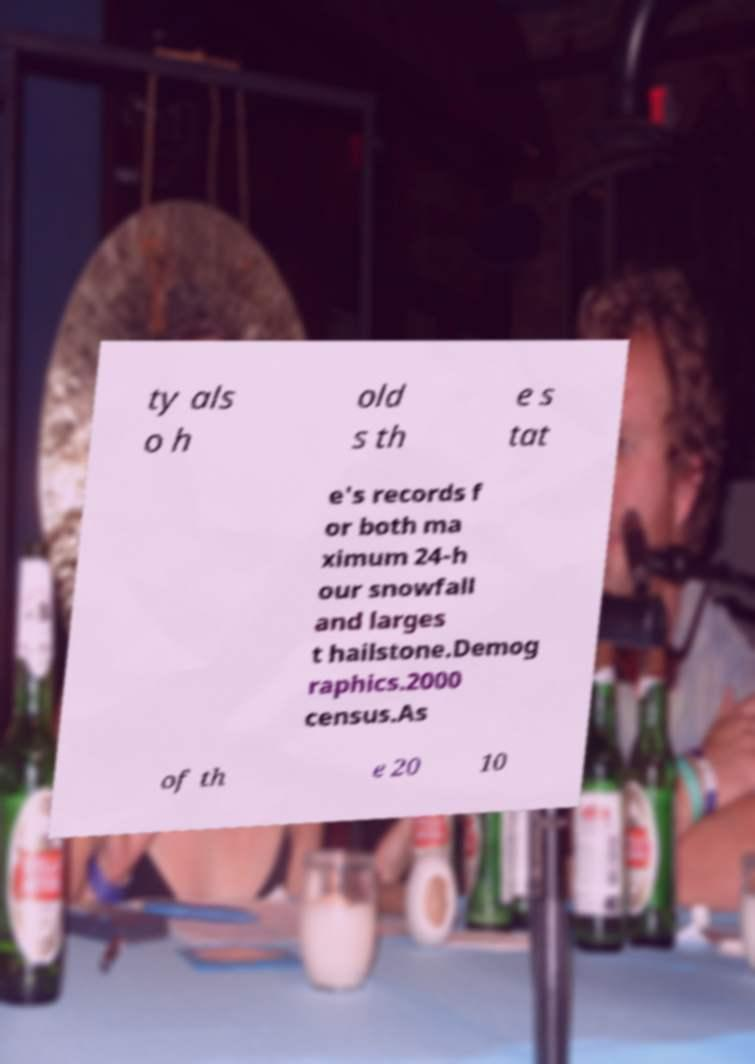Please read and relay the text visible in this image. What does it say? ty als o h old s th e s tat e's records f or both ma ximum 24-h our snowfall and larges t hailstone.Demog raphics.2000 census.As of th e 20 10 